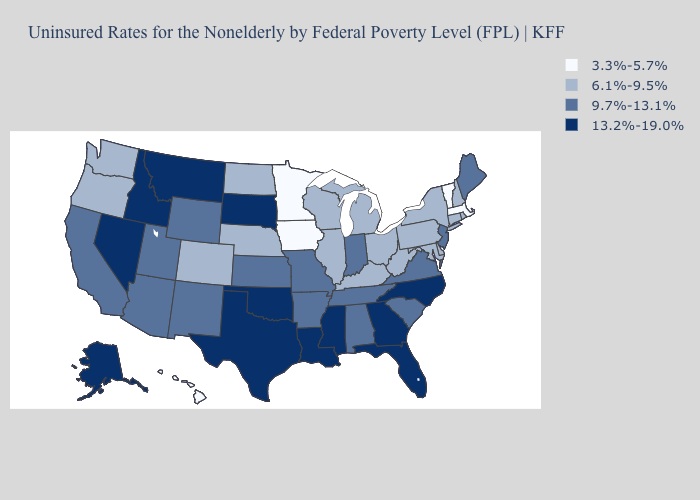What is the value of New Mexico?
Concise answer only. 9.7%-13.1%. What is the lowest value in the MidWest?
Concise answer only. 3.3%-5.7%. Name the states that have a value in the range 13.2%-19.0%?
Short answer required. Alaska, Florida, Georgia, Idaho, Louisiana, Mississippi, Montana, Nevada, North Carolina, Oklahoma, South Dakota, Texas. Name the states that have a value in the range 3.3%-5.7%?
Concise answer only. Hawaii, Iowa, Massachusetts, Minnesota, Vermont. What is the value of Nevada?
Be succinct. 13.2%-19.0%. Does the first symbol in the legend represent the smallest category?
Give a very brief answer. Yes. Does Minnesota have the lowest value in the MidWest?
Quick response, please. Yes. Does Delaware have the highest value in the South?
Answer briefly. No. What is the value of New York?
Write a very short answer. 6.1%-9.5%. Name the states that have a value in the range 3.3%-5.7%?
Keep it brief. Hawaii, Iowa, Massachusetts, Minnesota, Vermont. Does Nebraska have a higher value than Massachusetts?
Short answer required. Yes. Does Nebraska have the highest value in the USA?
Write a very short answer. No. Among the states that border Alabama , which have the lowest value?
Concise answer only. Tennessee. Name the states that have a value in the range 13.2%-19.0%?
Short answer required. Alaska, Florida, Georgia, Idaho, Louisiana, Mississippi, Montana, Nevada, North Carolina, Oklahoma, South Dakota, Texas. Does Indiana have a higher value than Utah?
Give a very brief answer. No. 